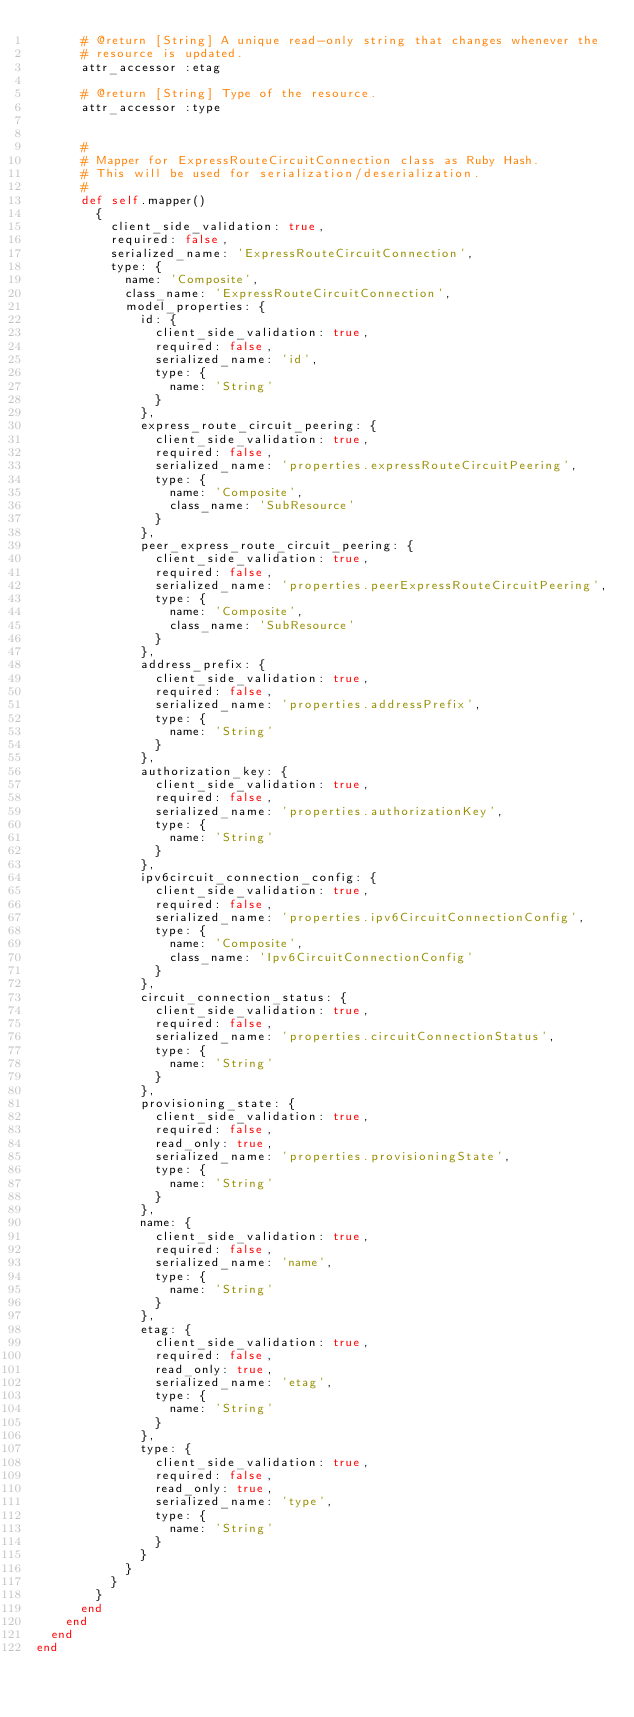<code> <loc_0><loc_0><loc_500><loc_500><_Ruby_>      # @return [String] A unique read-only string that changes whenever the
      # resource is updated.
      attr_accessor :etag

      # @return [String] Type of the resource.
      attr_accessor :type


      #
      # Mapper for ExpressRouteCircuitConnection class as Ruby Hash.
      # This will be used for serialization/deserialization.
      #
      def self.mapper()
        {
          client_side_validation: true,
          required: false,
          serialized_name: 'ExpressRouteCircuitConnection',
          type: {
            name: 'Composite',
            class_name: 'ExpressRouteCircuitConnection',
            model_properties: {
              id: {
                client_side_validation: true,
                required: false,
                serialized_name: 'id',
                type: {
                  name: 'String'
                }
              },
              express_route_circuit_peering: {
                client_side_validation: true,
                required: false,
                serialized_name: 'properties.expressRouteCircuitPeering',
                type: {
                  name: 'Composite',
                  class_name: 'SubResource'
                }
              },
              peer_express_route_circuit_peering: {
                client_side_validation: true,
                required: false,
                serialized_name: 'properties.peerExpressRouteCircuitPeering',
                type: {
                  name: 'Composite',
                  class_name: 'SubResource'
                }
              },
              address_prefix: {
                client_side_validation: true,
                required: false,
                serialized_name: 'properties.addressPrefix',
                type: {
                  name: 'String'
                }
              },
              authorization_key: {
                client_side_validation: true,
                required: false,
                serialized_name: 'properties.authorizationKey',
                type: {
                  name: 'String'
                }
              },
              ipv6circuit_connection_config: {
                client_side_validation: true,
                required: false,
                serialized_name: 'properties.ipv6CircuitConnectionConfig',
                type: {
                  name: 'Composite',
                  class_name: 'Ipv6CircuitConnectionConfig'
                }
              },
              circuit_connection_status: {
                client_side_validation: true,
                required: false,
                serialized_name: 'properties.circuitConnectionStatus',
                type: {
                  name: 'String'
                }
              },
              provisioning_state: {
                client_side_validation: true,
                required: false,
                read_only: true,
                serialized_name: 'properties.provisioningState',
                type: {
                  name: 'String'
                }
              },
              name: {
                client_side_validation: true,
                required: false,
                serialized_name: 'name',
                type: {
                  name: 'String'
                }
              },
              etag: {
                client_side_validation: true,
                required: false,
                read_only: true,
                serialized_name: 'etag',
                type: {
                  name: 'String'
                }
              },
              type: {
                client_side_validation: true,
                required: false,
                read_only: true,
                serialized_name: 'type',
                type: {
                  name: 'String'
                }
              }
            }
          }
        }
      end
    end
  end
end
</code> 